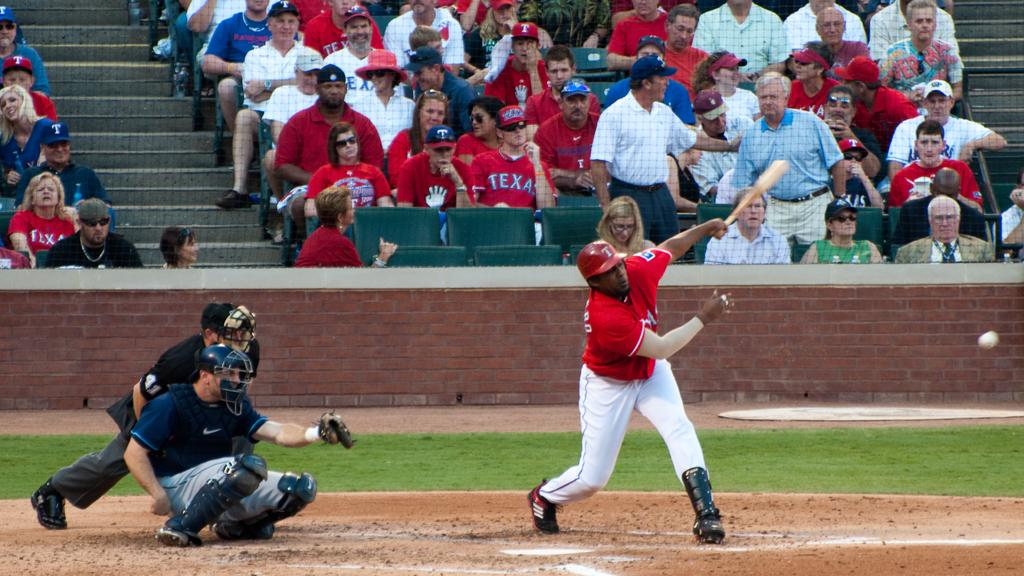<image>
Describe the image concisely. A man in a Texas shirt sits in the stands wearing sunglasses. 